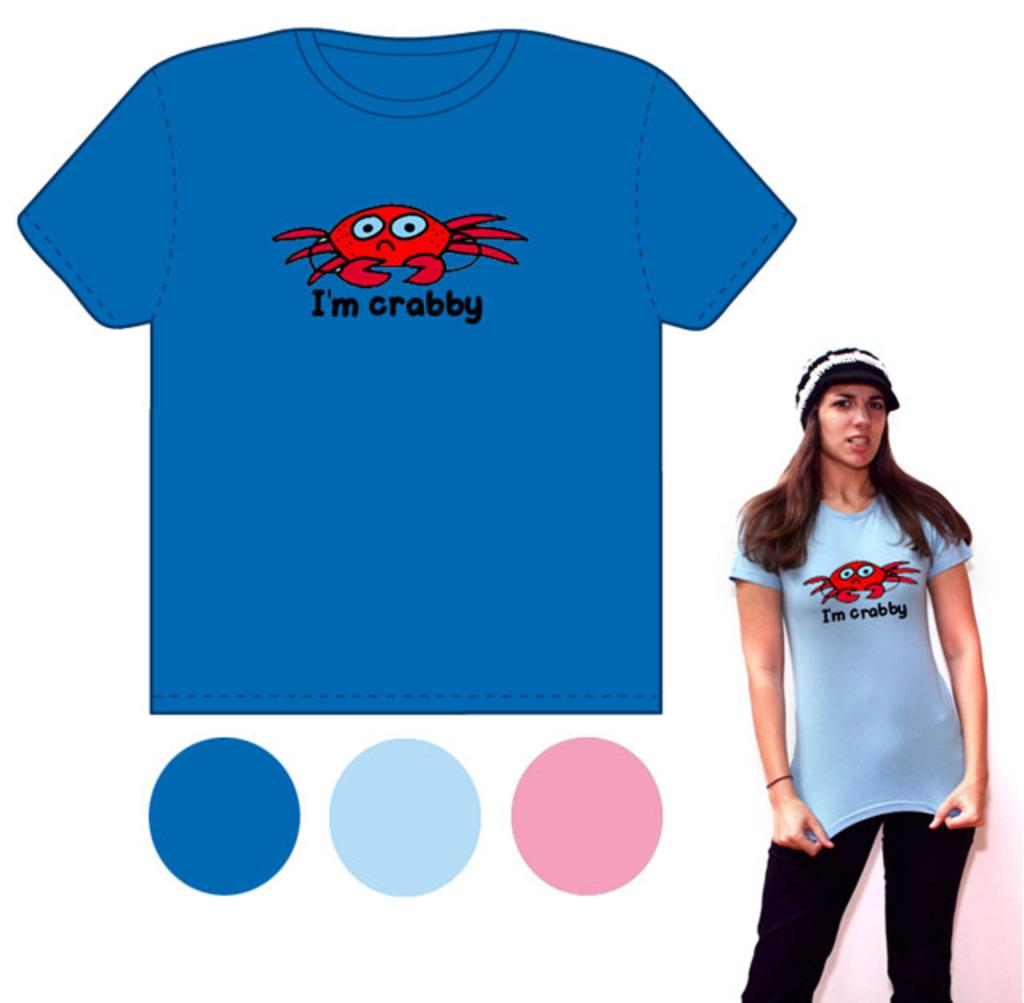<image>
Provide a brief description of the given image. A blue t-shirt with a red crab on the front and the wording I'm Crabby 